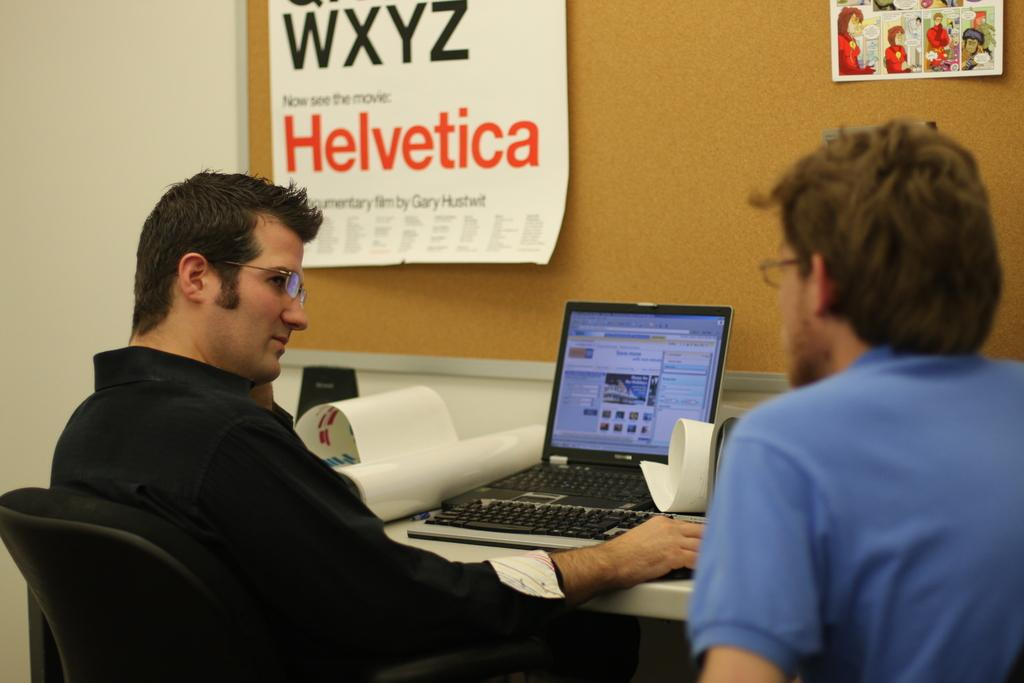<image>
Create a compact narrative representing the image presented. Two men in front of a computer and a sign that said Helvetica. 